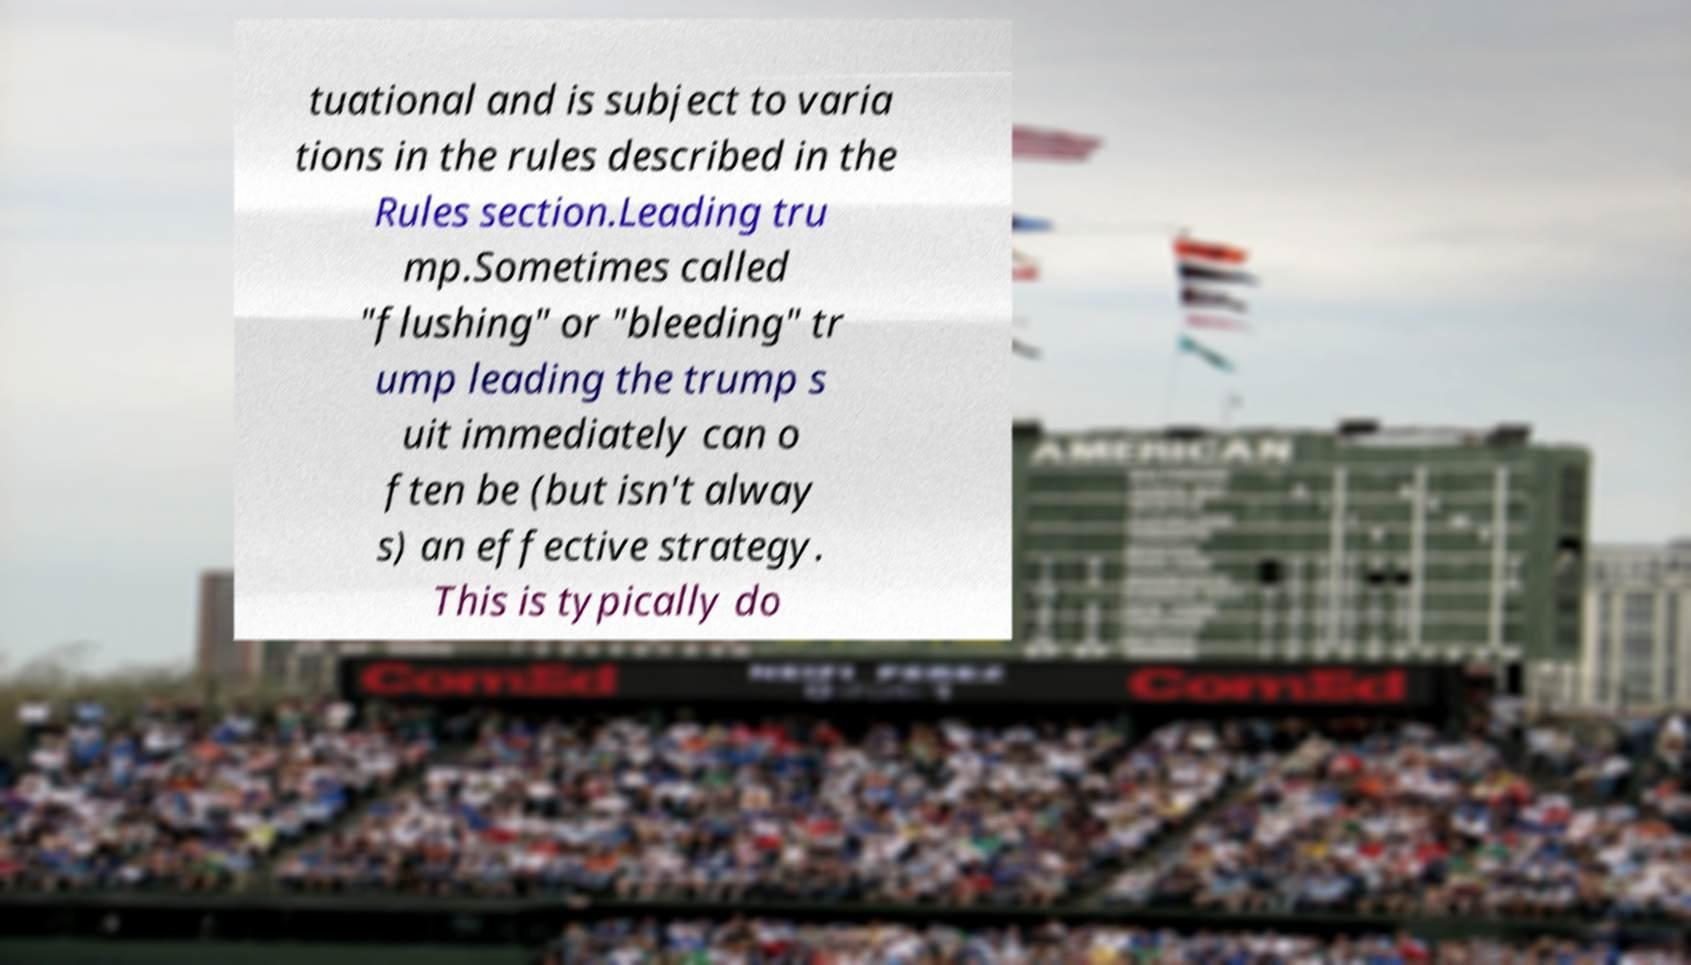Please identify and transcribe the text found in this image. tuational and is subject to varia tions in the rules described in the Rules section.Leading tru mp.Sometimes called "flushing" or "bleeding" tr ump leading the trump s uit immediately can o ften be (but isn't alway s) an effective strategy. This is typically do 